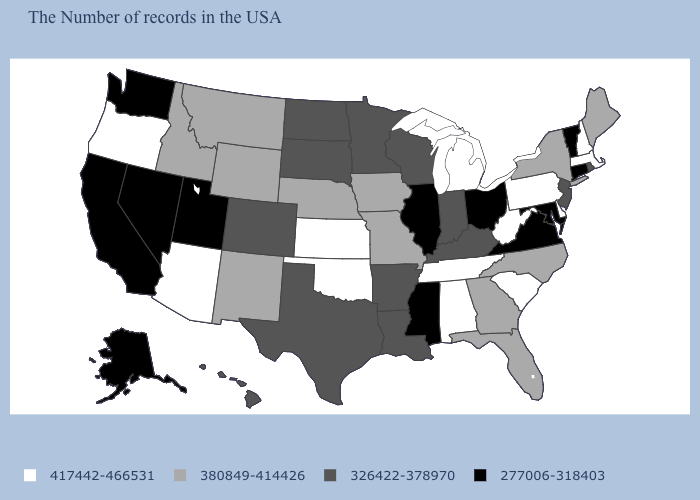What is the value of Wisconsin?
Short answer required. 326422-378970. What is the value of Pennsylvania?
Quick response, please. 417442-466531. Is the legend a continuous bar?
Short answer required. No. Does Arkansas have a lower value than Maine?
Be succinct. Yes. What is the highest value in the South ?
Answer briefly. 417442-466531. How many symbols are there in the legend?
Answer briefly. 4. Does the first symbol in the legend represent the smallest category?
Concise answer only. No. Name the states that have a value in the range 326422-378970?
Keep it brief. Rhode Island, New Jersey, Kentucky, Indiana, Wisconsin, Louisiana, Arkansas, Minnesota, Texas, South Dakota, North Dakota, Colorado, Hawaii. Does the map have missing data?
Be succinct. No. Does North Carolina have a lower value than Montana?
Give a very brief answer. No. What is the highest value in the MidWest ?
Answer briefly. 417442-466531. Is the legend a continuous bar?
Give a very brief answer. No. Which states hav the highest value in the MidWest?
Write a very short answer. Michigan, Kansas. Among the states that border Arkansas , which have the lowest value?
Concise answer only. Mississippi. What is the highest value in states that border Maryland?
Be succinct. 417442-466531. 